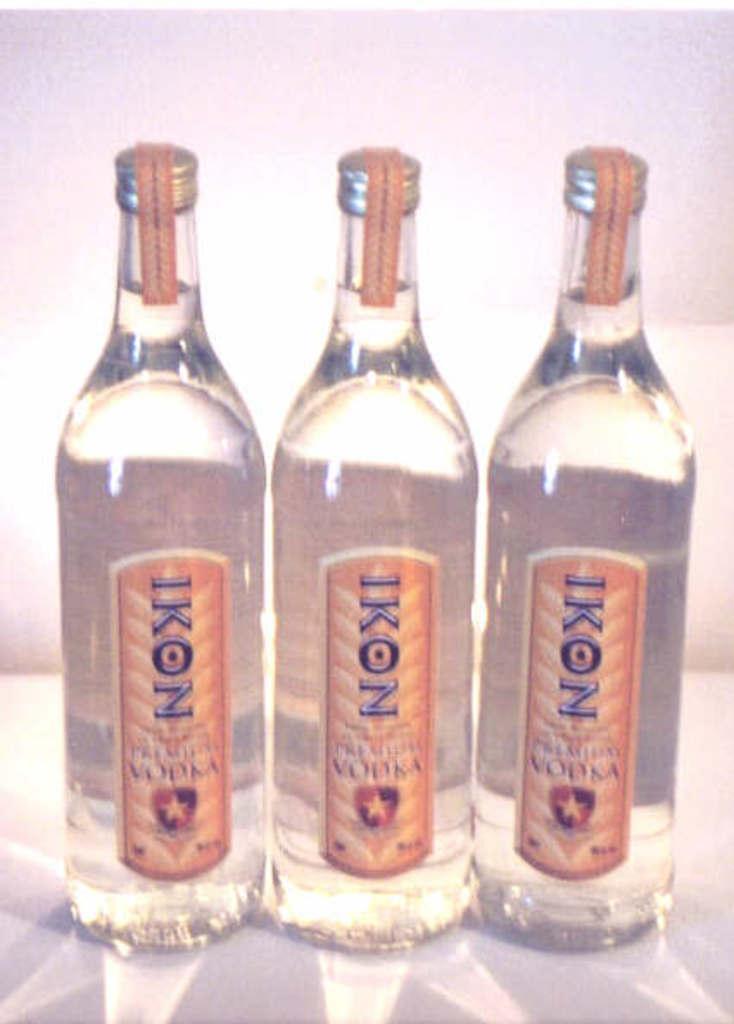In one or two sentences, can you explain what this image depicts? In the image we can see there are three bottles of vodka on which it's written "IKON". 